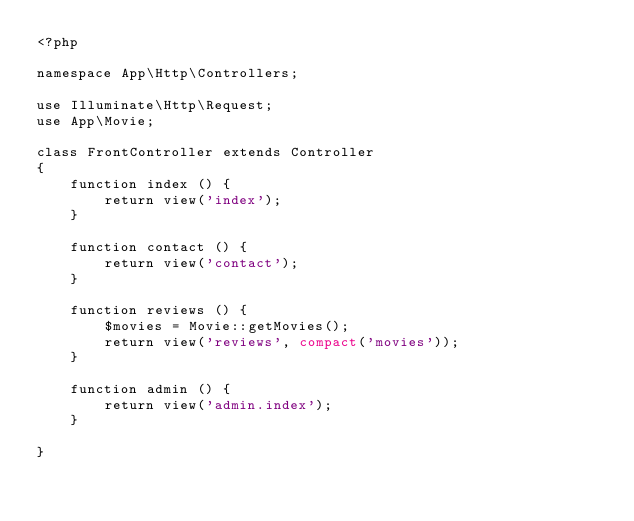Convert code to text. <code><loc_0><loc_0><loc_500><loc_500><_PHP_><?php

namespace App\Http\Controllers;

use Illuminate\Http\Request;
use App\Movie;

class FrontController extends Controller
{
    function index () {
        return view('index');
    }

    function contact () {
        return view('contact');
    }

    function reviews () {
        $movies = Movie::getMovies();
        return view('reviews', compact('movies'));
    }

    function admin () {
        return view('admin.index');
    }

}
</code> 